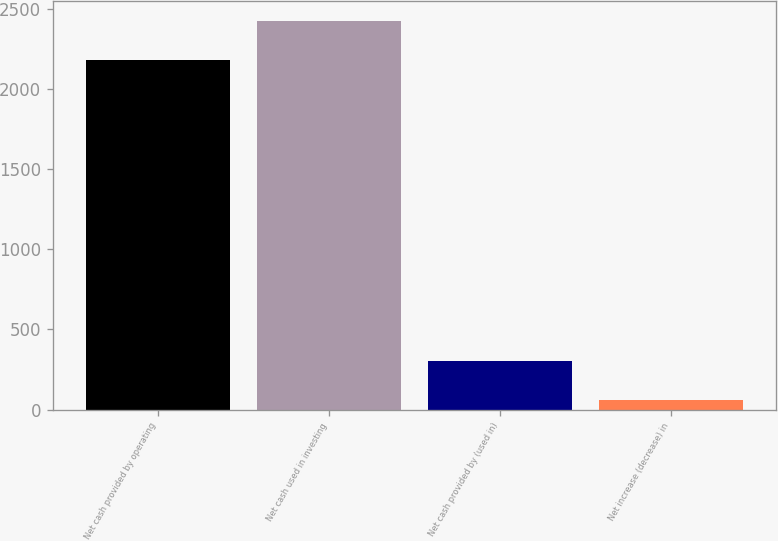Convert chart. <chart><loc_0><loc_0><loc_500><loc_500><bar_chart><fcel>Net cash provided by operating<fcel>Net cash used in investing<fcel>Net cash provided by (used in)<fcel>Net increase (decrease) in<nl><fcel>2180<fcel>2427<fcel>304<fcel>57<nl></chart> 